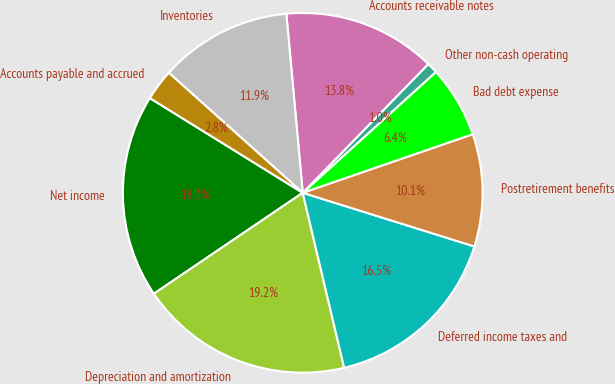<chart> <loc_0><loc_0><loc_500><loc_500><pie_chart><fcel>Net income<fcel>Depreciation and amortization<fcel>Deferred income taxes and<fcel>Postretirement benefits<fcel>Bad debt expense<fcel>Other non-cash operating<fcel>Accounts receivable notes<fcel>Inventories<fcel>Accounts payable and accrued<nl><fcel>18.31%<fcel>19.22%<fcel>16.48%<fcel>10.1%<fcel>6.45%<fcel>0.97%<fcel>13.75%<fcel>11.92%<fcel>2.8%<nl></chart> 